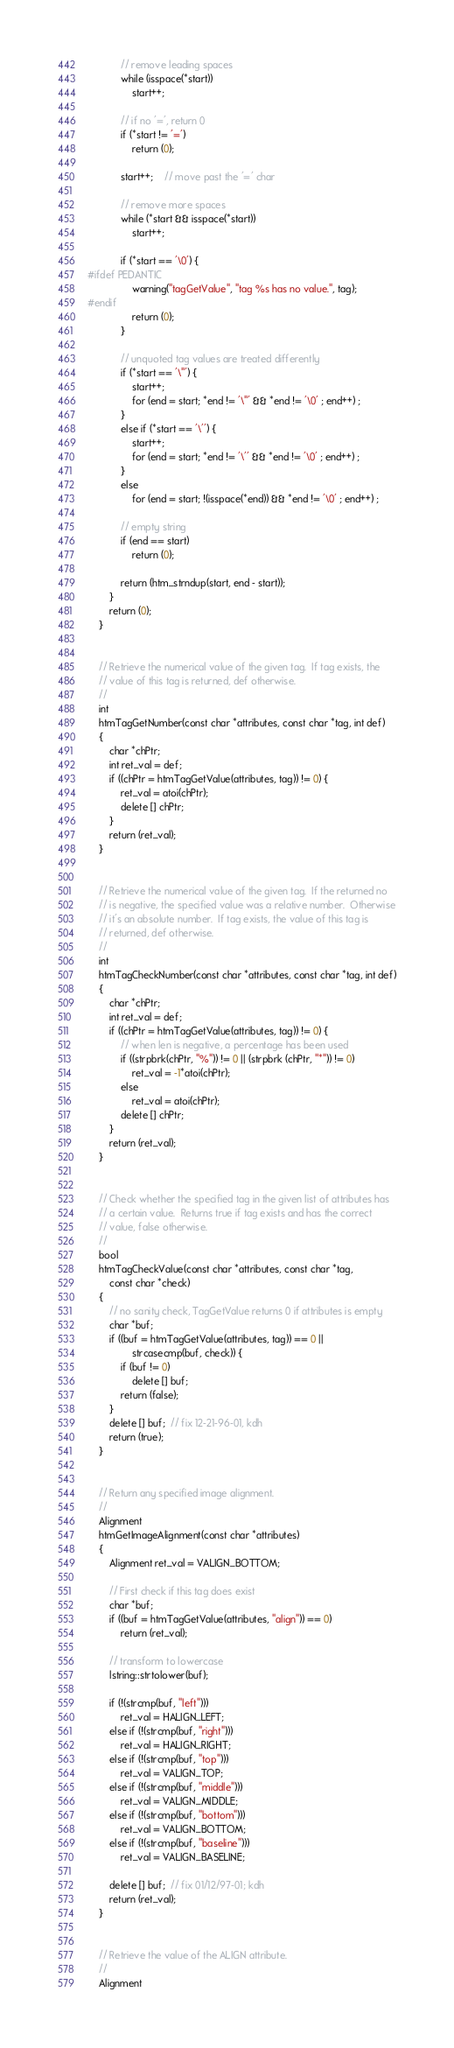Convert code to text. <code><loc_0><loc_0><loc_500><loc_500><_C++_>            // remove leading spaces
            while (isspace(*start))
                start++;

            // if no '=', return 0
            if (*start != '=')
                return (0);

            start++;    // move past the '=' char

            // remove more spaces
            while (*start && isspace(*start))
                start++;

            if (*start == '\0') {
#ifdef PEDANTIC
                warning("tagGetValue", "tag %s has no value.", tag);
#endif
                return (0);
            }

            // unquoted tag values are treated differently
            if (*start == '\"') {
                start++;
                for (end = start; *end != '\"' && *end != '\0' ; end++) ;
            }
            else if (*start == '\'') {
                start++;
                for (end = start; *end != '\'' && *end != '\0' ; end++) ;
            }
            else
                for (end = start; !(isspace(*end)) && *end != '\0' ; end++) ;

            // empty string
            if (end == start)
                return (0);

            return (htm_strndup(start, end - start));
        }
        return (0);
    }


    // Retrieve the numerical value of the given tag.  If tag exists, the
    // value of this tag is returned, def otherwise.
    //
    int
    htmTagGetNumber(const char *attributes, const char *tag, int def)
    {
        char *chPtr;
        int ret_val = def;
        if ((chPtr = htmTagGetValue(attributes, tag)) != 0) {
            ret_val = atoi(chPtr);
            delete [] chPtr;
        }
        return (ret_val);
    }


    // Retrieve the numerical value of the given tag.  If the returned no
    // is negative, the specified value was a relative number.  Otherwise
    // it's an absolute number.  If tag exists, the value of this tag is
    // returned, def otherwise.
    //
    int
    htmTagCheckNumber(const char *attributes, const char *tag, int def)
    {
        char *chPtr;
        int ret_val = def;
        if ((chPtr = htmTagGetValue(attributes, tag)) != 0) {
            // when len is negative, a percentage has been used
            if ((strpbrk(chPtr, "%")) != 0 || (strpbrk (chPtr, "*")) != 0)
                ret_val = -1*atoi(chPtr);
            else
                ret_val = atoi(chPtr);
            delete [] chPtr;
        }
        return (ret_val);
    }


    // Check whether the specified tag in the given list of attributes has
    // a certain value.  Returns true if tag exists and has the correct
    // value, false otherwise.
    //
    bool
    htmTagCheckValue(const char *attributes, const char *tag,
        const char *check)
    {
        // no sanity check, TagGetValue returns 0 if attributes is empty
        char *buf;
        if ((buf = htmTagGetValue(attributes, tag)) == 0 ||
                strcasecmp(buf, check)) {
            if (buf != 0)
                delete [] buf;
            return (false);
        }
        delete [] buf;  // fix 12-21-96-01, kdh
        return (true);
    }


    // Return any specified image alignment.
    //
    Alignment
    htmGetImageAlignment(const char *attributes)
    {
        Alignment ret_val = VALIGN_BOTTOM;

        // First check if this tag does exist
        char *buf;
        if ((buf = htmTagGetValue(attributes, "align")) == 0)
            return (ret_val);

        // transform to lowercase
        lstring::strtolower(buf);

        if (!(strcmp(buf, "left")))
            ret_val = HALIGN_LEFT;
        else if (!(strcmp(buf, "right")))
            ret_val = HALIGN_RIGHT;
        else if (!(strcmp(buf, "top")))
            ret_val = VALIGN_TOP;
        else if (!(strcmp(buf, "middle")))
            ret_val = VALIGN_MIDDLE;
        else if (!(strcmp(buf, "bottom")))
            ret_val = VALIGN_BOTTOM;
        else if (!(strcmp(buf, "baseline")))
            ret_val = VALIGN_BASELINE;

        delete [] buf;  // fix 01/12/97-01; kdh
        return (ret_val);
    }


    // Retrieve the value of the ALIGN attribute.
    //
    Alignment</code> 